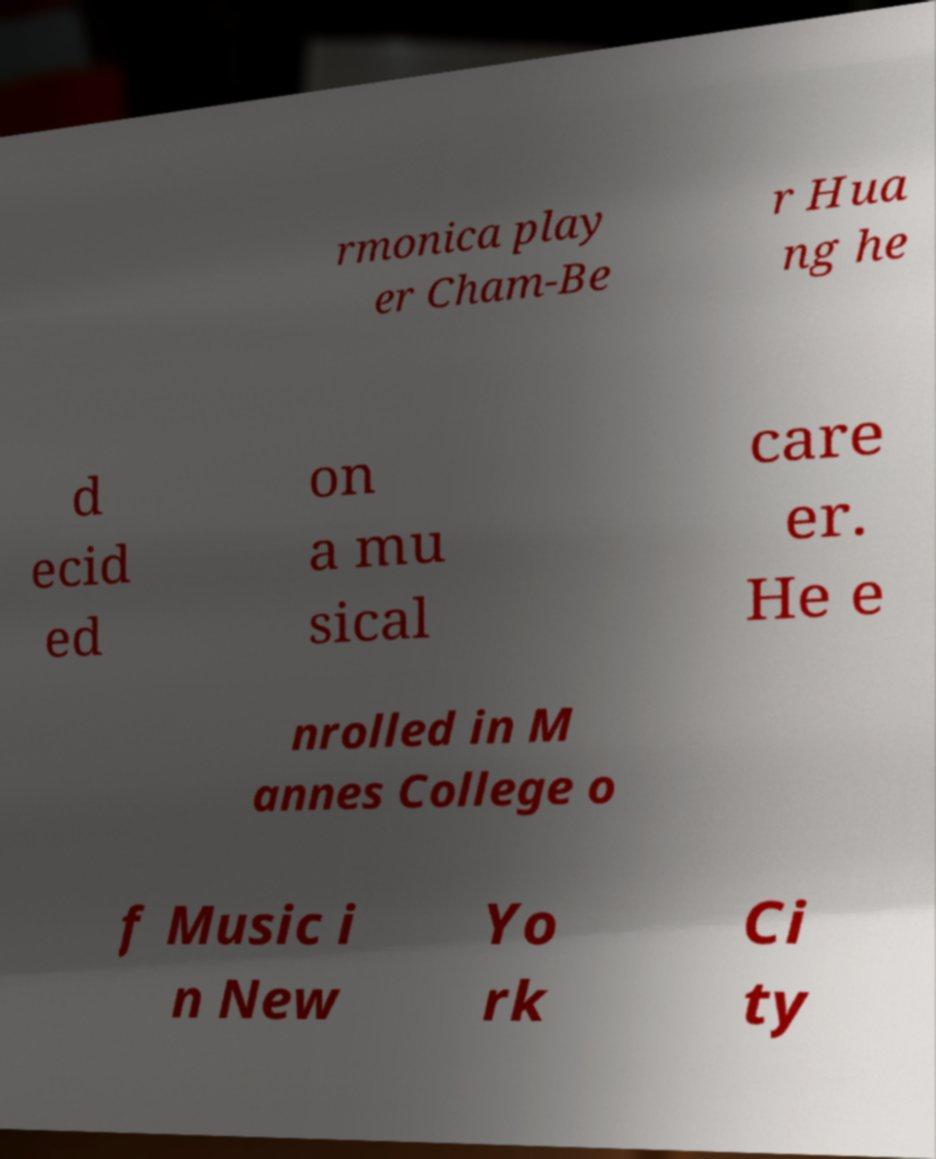Please read and relay the text visible in this image. What does it say? rmonica play er Cham-Be r Hua ng he d ecid ed on a mu sical care er. He e nrolled in M annes College o f Music i n New Yo rk Ci ty 